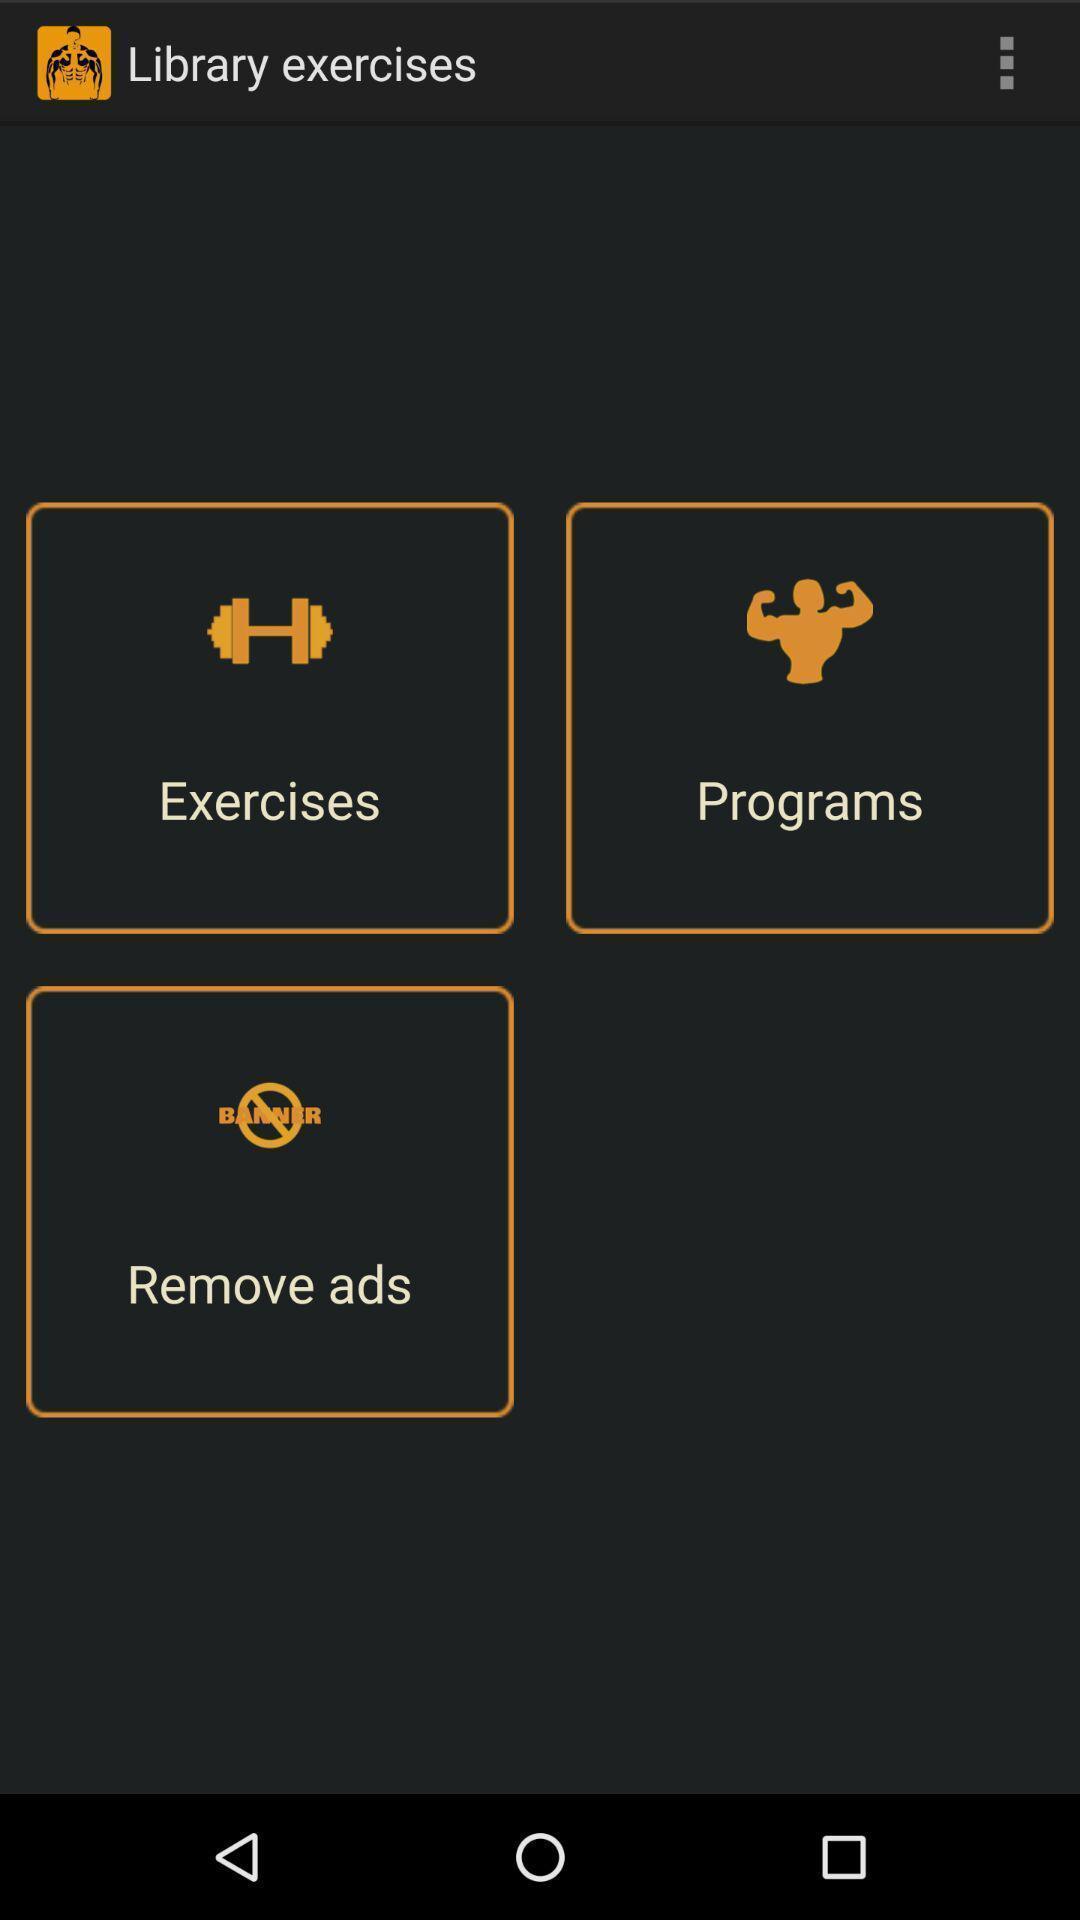Tell me about the visual elements in this screen capture. Page displaying various options in fitness application. 